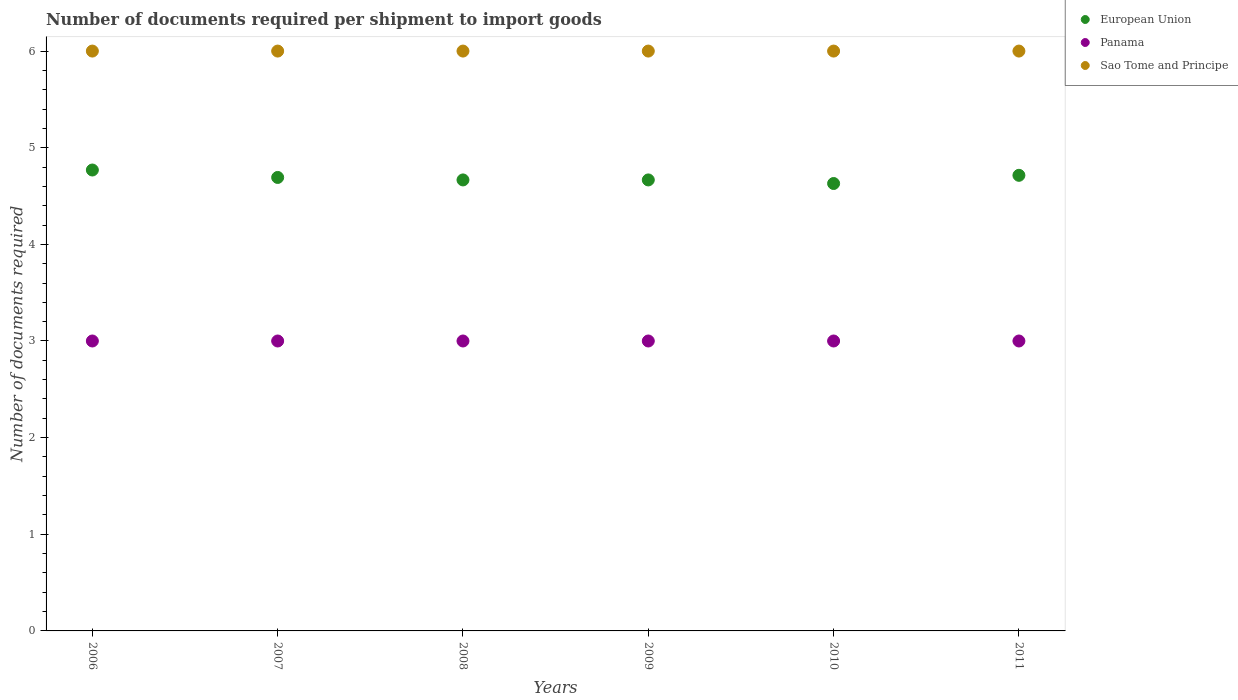What is the number of documents required per shipment to import goods in Panama in 2007?
Your response must be concise. 3. Across all years, what is the maximum number of documents required per shipment to import goods in Panama?
Provide a short and direct response. 3. Across all years, what is the minimum number of documents required per shipment to import goods in Panama?
Keep it short and to the point. 3. In which year was the number of documents required per shipment to import goods in Sao Tome and Principe maximum?
Your answer should be very brief. 2006. What is the total number of documents required per shipment to import goods in Panama in the graph?
Keep it short and to the point. 18. What is the difference between the number of documents required per shipment to import goods in Sao Tome and Principe in 2011 and the number of documents required per shipment to import goods in European Union in 2009?
Your answer should be compact. 1.33. What is the average number of documents required per shipment to import goods in Sao Tome and Principe per year?
Give a very brief answer. 6. In the year 2009, what is the difference between the number of documents required per shipment to import goods in Sao Tome and Principe and number of documents required per shipment to import goods in European Union?
Ensure brevity in your answer.  1.33. In how many years, is the number of documents required per shipment to import goods in Panama greater than 5?
Ensure brevity in your answer.  0. What is the ratio of the number of documents required per shipment to import goods in European Union in 2006 to that in 2008?
Ensure brevity in your answer.  1.02. Is the difference between the number of documents required per shipment to import goods in Sao Tome and Principe in 2007 and 2009 greater than the difference between the number of documents required per shipment to import goods in European Union in 2007 and 2009?
Keep it short and to the point. No. What is the difference between the highest and the second highest number of documents required per shipment to import goods in Panama?
Your response must be concise. 0. What is the difference between the highest and the lowest number of documents required per shipment to import goods in Panama?
Offer a very short reply. 0. Is the sum of the number of documents required per shipment to import goods in Panama in 2009 and 2011 greater than the maximum number of documents required per shipment to import goods in Sao Tome and Principe across all years?
Your answer should be compact. No. How many years are there in the graph?
Offer a terse response. 6. What is the difference between two consecutive major ticks on the Y-axis?
Give a very brief answer. 1. Are the values on the major ticks of Y-axis written in scientific E-notation?
Offer a terse response. No. Does the graph contain any zero values?
Provide a succinct answer. No. Does the graph contain grids?
Provide a short and direct response. No. Where does the legend appear in the graph?
Make the answer very short. Top right. How many legend labels are there?
Make the answer very short. 3. What is the title of the graph?
Your answer should be compact. Number of documents required per shipment to import goods. Does "Solomon Islands" appear as one of the legend labels in the graph?
Your answer should be very brief. No. What is the label or title of the Y-axis?
Your answer should be very brief. Number of documents required. What is the Number of documents required of European Union in 2006?
Keep it short and to the point. 4.77. What is the Number of documents required of European Union in 2007?
Provide a short and direct response. 4.69. What is the Number of documents required in European Union in 2008?
Make the answer very short. 4.67. What is the Number of documents required in Sao Tome and Principe in 2008?
Make the answer very short. 6. What is the Number of documents required in European Union in 2009?
Offer a very short reply. 4.67. What is the Number of documents required of Sao Tome and Principe in 2009?
Offer a terse response. 6. What is the Number of documents required in European Union in 2010?
Ensure brevity in your answer.  4.63. What is the Number of documents required in Panama in 2010?
Keep it short and to the point. 3. What is the Number of documents required of Sao Tome and Principe in 2010?
Keep it short and to the point. 6. What is the Number of documents required of European Union in 2011?
Give a very brief answer. 4.71. What is the Number of documents required in Sao Tome and Principe in 2011?
Your response must be concise. 6. Across all years, what is the maximum Number of documents required of European Union?
Offer a terse response. 4.77. Across all years, what is the minimum Number of documents required in European Union?
Offer a very short reply. 4.63. Across all years, what is the minimum Number of documents required of Panama?
Ensure brevity in your answer.  3. Across all years, what is the minimum Number of documents required of Sao Tome and Principe?
Keep it short and to the point. 6. What is the total Number of documents required of European Union in the graph?
Ensure brevity in your answer.  28.14. What is the total Number of documents required in Panama in the graph?
Ensure brevity in your answer.  18. What is the difference between the Number of documents required of European Union in 2006 and that in 2007?
Give a very brief answer. 0.08. What is the difference between the Number of documents required in Sao Tome and Principe in 2006 and that in 2007?
Ensure brevity in your answer.  0. What is the difference between the Number of documents required in European Union in 2006 and that in 2008?
Give a very brief answer. 0.1. What is the difference between the Number of documents required of European Union in 2006 and that in 2009?
Your response must be concise. 0.1. What is the difference between the Number of documents required in European Union in 2006 and that in 2010?
Provide a succinct answer. 0.14. What is the difference between the Number of documents required in Panama in 2006 and that in 2010?
Make the answer very short. 0. What is the difference between the Number of documents required of Sao Tome and Principe in 2006 and that in 2010?
Offer a very short reply. 0. What is the difference between the Number of documents required of European Union in 2006 and that in 2011?
Offer a terse response. 0.05. What is the difference between the Number of documents required in Panama in 2006 and that in 2011?
Your answer should be very brief. 0. What is the difference between the Number of documents required of European Union in 2007 and that in 2008?
Offer a very short reply. 0.03. What is the difference between the Number of documents required of Sao Tome and Principe in 2007 and that in 2008?
Ensure brevity in your answer.  0. What is the difference between the Number of documents required of European Union in 2007 and that in 2009?
Provide a succinct answer. 0.03. What is the difference between the Number of documents required in Panama in 2007 and that in 2009?
Your answer should be very brief. 0. What is the difference between the Number of documents required in Sao Tome and Principe in 2007 and that in 2009?
Provide a short and direct response. 0. What is the difference between the Number of documents required in European Union in 2007 and that in 2010?
Offer a very short reply. 0.06. What is the difference between the Number of documents required of European Union in 2007 and that in 2011?
Offer a very short reply. -0.02. What is the difference between the Number of documents required of Panama in 2007 and that in 2011?
Provide a succinct answer. 0. What is the difference between the Number of documents required of European Union in 2008 and that in 2009?
Provide a succinct answer. 0. What is the difference between the Number of documents required of Sao Tome and Principe in 2008 and that in 2009?
Offer a very short reply. 0. What is the difference between the Number of documents required in European Union in 2008 and that in 2010?
Provide a succinct answer. 0.04. What is the difference between the Number of documents required in European Union in 2008 and that in 2011?
Give a very brief answer. -0.05. What is the difference between the Number of documents required of Sao Tome and Principe in 2008 and that in 2011?
Your answer should be compact. 0. What is the difference between the Number of documents required in European Union in 2009 and that in 2010?
Your answer should be very brief. 0.04. What is the difference between the Number of documents required of European Union in 2009 and that in 2011?
Your answer should be compact. -0.05. What is the difference between the Number of documents required of Panama in 2009 and that in 2011?
Keep it short and to the point. 0. What is the difference between the Number of documents required in European Union in 2010 and that in 2011?
Keep it short and to the point. -0.08. What is the difference between the Number of documents required of European Union in 2006 and the Number of documents required of Panama in 2007?
Provide a succinct answer. 1.77. What is the difference between the Number of documents required in European Union in 2006 and the Number of documents required in Sao Tome and Principe in 2007?
Offer a very short reply. -1.23. What is the difference between the Number of documents required in Panama in 2006 and the Number of documents required in Sao Tome and Principe in 2007?
Provide a succinct answer. -3. What is the difference between the Number of documents required of European Union in 2006 and the Number of documents required of Panama in 2008?
Provide a short and direct response. 1.77. What is the difference between the Number of documents required in European Union in 2006 and the Number of documents required in Sao Tome and Principe in 2008?
Keep it short and to the point. -1.23. What is the difference between the Number of documents required in Panama in 2006 and the Number of documents required in Sao Tome and Principe in 2008?
Provide a succinct answer. -3. What is the difference between the Number of documents required of European Union in 2006 and the Number of documents required of Panama in 2009?
Provide a short and direct response. 1.77. What is the difference between the Number of documents required of European Union in 2006 and the Number of documents required of Sao Tome and Principe in 2009?
Your answer should be compact. -1.23. What is the difference between the Number of documents required in Panama in 2006 and the Number of documents required in Sao Tome and Principe in 2009?
Give a very brief answer. -3. What is the difference between the Number of documents required in European Union in 2006 and the Number of documents required in Panama in 2010?
Ensure brevity in your answer.  1.77. What is the difference between the Number of documents required in European Union in 2006 and the Number of documents required in Sao Tome and Principe in 2010?
Your answer should be very brief. -1.23. What is the difference between the Number of documents required in Panama in 2006 and the Number of documents required in Sao Tome and Principe in 2010?
Your response must be concise. -3. What is the difference between the Number of documents required in European Union in 2006 and the Number of documents required in Panama in 2011?
Your answer should be very brief. 1.77. What is the difference between the Number of documents required in European Union in 2006 and the Number of documents required in Sao Tome and Principe in 2011?
Keep it short and to the point. -1.23. What is the difference between the Number of documents required in European Union in 2007 and the Number of documents required in Panama in 2008?
Keep it short and to the point. 1.69. What is the difference between the Number of documents required in European Union in 2007 and the Number of documents required in Sao Tome and Principe in 2008?
Your answer should be compact. -1.31. What is the difference between the Number of documents required of European Union in 2007 and the Number of documents required of Panama in 2009?
Your answer should be compact. 1.69. What is the difference between the Number of documents required in European Union in 2007 and the Number of documents required in Sao Tome and Principe in 2009?
Provide a short and direct response. -1.31. What is the difference between the Number of documents required of European Union in 2007 and the Number of documents required of Panama in 2010?
Ensure brevity in your answer.  1.69. What is the difference between the Number of documents required of European Union in 2007 and the Number of documents required of Sao Tome and Principe in 2010?
Make the answer very short. -1.31. What is the difference between the Number of documents required of European Union in 2007 and the Number of documents required of Panama in 2011?
Keep it short and to the point. 1.69. What is the difference between the Number of documents required of European Union in 2007 and the Number of documents required of Sao Tome and Principe in 2011?
Ensure brevity in your answer.  -1.31. What is the difference between the Number of documents required in Panama in 2007 and the Number of documents required in Sao Tome and Principe in 2011?
Your answer should be compact. -3. What is the difference between the Number of documents required in European Union in 2008 and the Number of documents required in Panama in 2009?
Your response must be concise. 1.67. What is the difference between the Number of documents required of European Union in 2008 and the Number of documents required of Sao Tome and Principe in 2009?
Keep it short and to the point. -1.33. What is the difference between the Number of documents required in European Union in 2008 and the Number of documents required in Sao Tome and Principe in 2010?
Provide a succinct answer. -1.33. What is the difference between the Number of documents required in Panama in 2008 and the Number of documents required in Sao Tome and Principe in 2010?
Give a very brief answer. -3. What is the difference between the Number of documents required in European Union in 2008 and the Number of documents required in Panama in 2011?
Your answer should be very brief. 1.67. What is the difference between the Number of documents required of European Union in 2008 and the Number of documents required of Sao Tome and Principe in 2011?
Provide a short and direct response. -1.33. What is the difference between the Number of documents required in European Union in 2009 and the Number of documents required in Sao Tome and Principe in 2010?
Your answer should be compact. -1.33. What is the difference between the Number of documents required in Panama in 2009 and the Number of documents required in Sao Tome and Principe in 2010?
Ensure brevity in your answer.  -3. What is the difference between the Number of documents required in European Union in 2009 and the Number of documents required in Sao Tome and Principe in 2011?
Your response must be concise. -1.33. What is the difference between the Number of documents required of European Union in 2010 and the Number of documents required of Panama in 2011?
Make the answer very short. 1.63. What is the difference between the Number of documents required in European Union in 2010 and the Number of documents required in Sao Tome and Principe in 2011?
Make the answer very short. -1.37. What is the average Number of documents required in European Union per year?
Your answer should be compact. 4.69. In the year 2006, what is the difference between the Number of documents required of European Union and Number of documents required of Panama?
Offer a very short reply. 1.77. In the year 2006, what is the difference between the Number of documents required in European Union and Number of documents required in Sao Tome and Principe?
Offer a terse response. -1.23. In the year 2007, what is the difference between the Number of documents required in European Union and Number of documents required in Panama?
Your answer should be compact. 1.69. In the year 2007, what is the difference between the Number of documents required in European Union and Number of documents required in Sao Tome and Principe?
Keep it short and to the point. -1.31. In the year 2007, what is the difference between the Number of documents required of Panama and Number of documents required of Sao Tome and Principe?
Offer a terse response. -3. In the year 2008, what is the difference between the Number of documents required in European Union and Number of documents required in Sao Tome and Principe?
Keep it short and to the point. -1.33. In the year 2009, what is the difference between the Number of documents required in European Union and Number of documents required in Panama?
Provide a short and direct response. 1.67. In the year 2009, what is the difference between the Number of documents required of European Union and Number of documents required of Sao Tome and Principe?
Offer a terse response. -1.33. In the year 2010, what is the difference between the Number of documents required of European Union and Number of documents required of Panama?
Keep it short and to the point. 1.63. In the year 2010, what is the difference between the Number of documents required of European Union and Number of documents required of Sao Tome and Principe?
Your answer should be very brief. -1.37. In the year 2011, what is the difference between the Number of documents required in European Union and Number of documents required in Panama?
Your response must be concise. 1.71. In the year 2011, what is the difference between the Number of documents required in European Union and Number of documents required in Sao Tome and Principe?
Offer a very short reply. -1.29. What is the ratio of the Number of documents required in European Union in 2006 to that in 2007?
Give a very brief answer. 1.02. What is the ratio of the Number of documents required of European Union in 2006 to that in 2008?
Give a very brief answer. 1.02. What is the ratio of the Number of documents required in Sao Tome and Principe in 2006 to that in 2008?
Offer a terse response. 1. What is the ratio of the Number of documents required in Sao Tome and Principe in 2006 to that in 2009?
Keep it short and to the point. 1. What is the ratio of the Number of documents required of European Union in 2006 to that in 2010?
Provide a succinct answer. 1.03. What is the ratio of the Number of documents required of Panama in 2006 to that in 2010?
Provide a succinct answer. 1. What is the ratio of the Number of documents required of European Union in 2006 to that in 2011?
Give a very brief answer. 1.01. What is the ratio of the Number of documents required of Sao Tome and Principe in 2006 to that in 2011?
Give a very brief answer. 1. What is the ratio of the Number of documents required of European Union in 2007 to that in 2008?
Provide a short and direct response. 1.01. What is the ratio of the Number of documents required in Panama in 2007 to that in 2008?
Your answer should be very brief. 1. What is the ratio of the Number of documents required of Panama in 2007 to that in 2009?
Provide a succinct answer. 1. What is the ratio of the Number of documents required of European Union in 2007 to that in 2010?
Your answer should be very brief. 1.01. What is the ratio of the Number of documents required of Panama in 2007 to that in 2010?
Offer a terse response. 1. What is the ratio of the Number of documents required in Panama in 2008 to that in 2009?
Ensure brevity in your answer.  1. What is the ratio of the Number of documents required of Sao Tome and Principe in 2008 to that in 2009?
Ensure brevity in your answer.  1. What is the ratio of the Number of documents required in European Union in 2008 to that in 2010?
Your answer should be compact. 1.01. What is the ratio of the Number of documents required in Sao Tome and Principe in 2008 to that in 2010?
Offer a very short reply. 1. What is the ratio of the Number of documents required in Panama in 2008 to that in 2011?
Give a very brief answer. 1. What is the ratio of the Number of documents required in Sao Tome and Principe in 2008 to that in 2011?
Your answer should be compact. 1. What is the ratio of the Number of documents required of Panama in 2009 to that in 2010?
Provide a succinct answer. 1. What is the ratio of the Number of documents required of Sao Tome and Principe in 2009 to that in 2010?
Your answer should be compact. 1. What is the ratio of the Number of documents required in Panama in 2009 to that in 2011?
Ensure brevity in your answer.  1. What is the ratio of the Number of documents required in European Union in 2010 to that in 2011?
Ensure brevity in your answer.  0.98. What is the ratio of the Number of documents required of Sao Tome and Principe in 2010 to that in 2011?
Keep it short and to the point. 1. What is the difference between the highest and the second highest Number of documents required of European Union?
Ensure brevity in your answer.  0.05. What is the difference between the highest and the second highest Number of documents required of Panama?
Make the answer very short. 0. What is the difference between the highest and the lowest Number of documents required in European Union?
Ensure brevity in your answer.  0.14. 